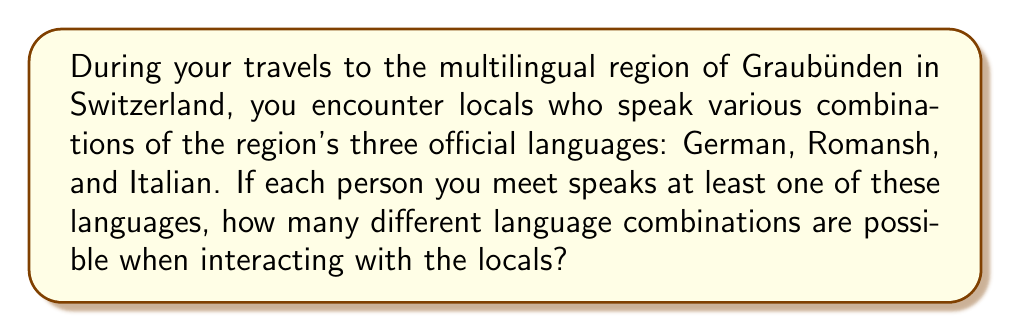Could you help me with this problem? Let's approach this step-by-step:

1) First, we need to consider all possible combinations of languages a person might speak. We can use the concept of power sets to solve this.

2) With 3 languages, we have $2^3 = 8$ possible combinations. However, we need to exclude the case where a person speaks no languages at all, as the question states that each person speaks at least one language.

3) Let's list out all possibilities:
   - German only
   - Romansh only
   - Italian only
   - German and Romansh
   - German and Italian
   - Romansh and Italian
   - All three languages

4) We can also think of this mathematically:
   $$\text{Total combinations} = 2^3 - 1 = 8 - 1 = 7$$

   Where:
   - $2^3$ represents all possible combinations (including speaking no languages)
   - We subtract 1 to exclude the case of speaking no languages

5) Therefore, there are 7 different language combinations possible when interacting with locals in this multilingual region.
Answer: 7 